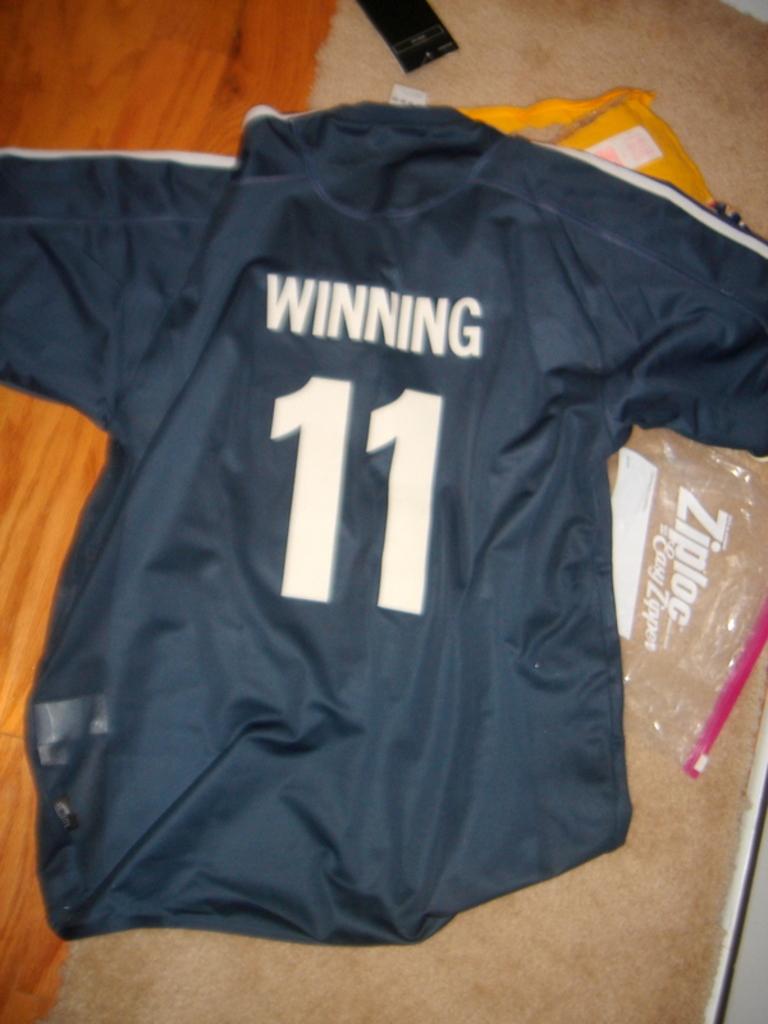What is the name on the jersey?
Offer a terse response. Winning. 